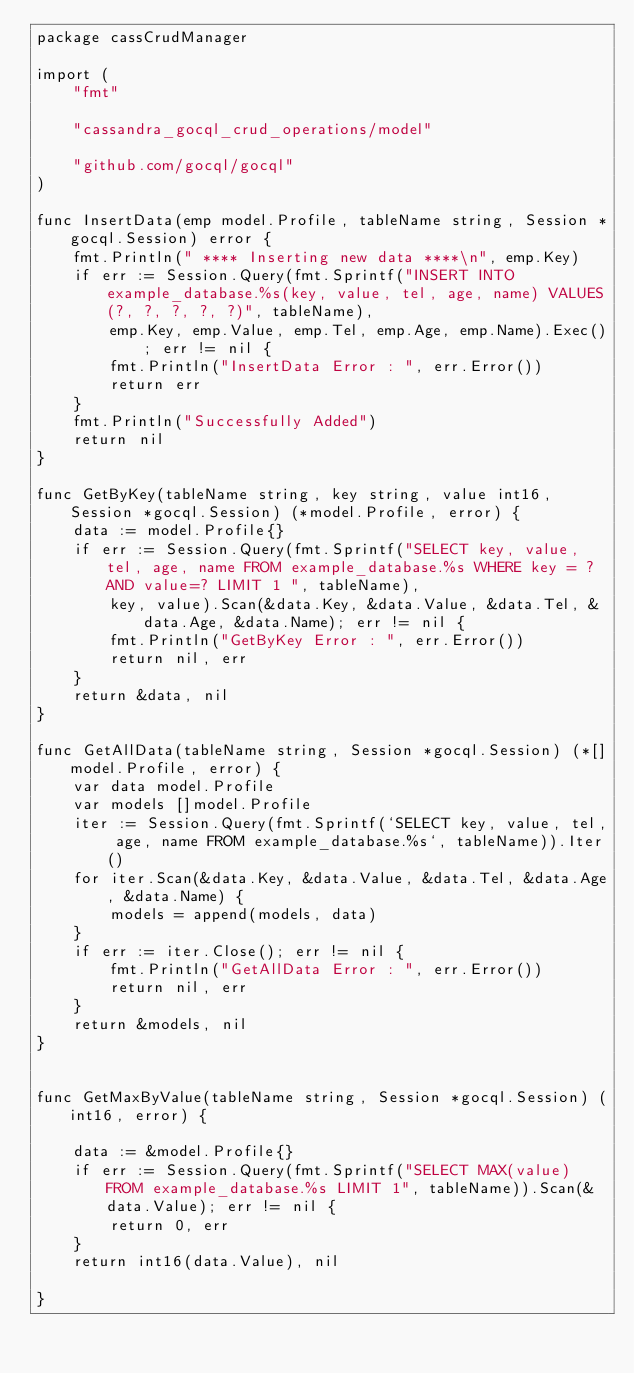<code> <loc_0><loc_0><loc_500><loc_500><_Go_>package cassCrudManager

import (
	"fmt"

	"cassandra_gocql_crud_operations/model"

	"github.com/gocql/gocql"
)

func InsertData(emp model.Profile, tableName string, Session *gocql.Session) error {
	fmt.Println(" **** Inserting new data ****\n", emp.Key)
	if err := Session.Query(fmt.Sprintf("INSERT INTO example_database.%s(key, value, tel, age, name) VALUES(?, ?, ?, ?, ?)", tableName),
		emp.Key, emp.Value, emp.Tel, emp.Age, emp.Name).Exec(); err != nil {
		fmt.Println("InsertData Error : ", err.Error())
		return err
	}
	fmt.Println("Successfully Added")
	return nil
}

func GetByKey(tableName string, key string, value int16, Session *gocql.Session) (*model.Profile, error) {
	data := model.Profile{}
	if err := Session.Query(fmt.Sprintf("SELECT key, value, tel, age, name FROM example_database.%s WHERE key = ? AND value=? LIMIT 1 ", tableName),
		key, value).Scan(&data.Key, &data.Value, &data.Tel, &data.Age, &data.Name); err != nil {
		fmt.Println("GetByKey Error : ", err.Error())
		return nil, err
	}
	return &data, nil
}

func GetAllData(tableName string, Session *gocql.Session) (*[]model.Profile, error) {
	var data model.Profile
	var models []model.Profile
	iter := Session.Query(fmt.Sprintf(`SELECT key, value, tel, age, name FROM example_database.%s`, tableName)).Iter()
	for iter.Scan(&data.Key, &data.Value, &data.Tel, &data.Age, &data.Name) {
		models = append(models, data)
	}
	if err := iter.Close(); err != nil {
		fmt.Println("GetAllData Error : ", err.Error())
		return nil, err
	}
	return &models, nil
}


func GetMaxByValue(tableName string, Session *gocql.Session) (int16, error) {

	data := &model.Profile{}
	if err := Session.Query(fmt.Sprintf("SELECT MAX(value) FROM example_database.%s LIMIT 1", tableName)).Scan(&data.Value); err != nil {
		return 0, err
	}
	return int16(data.Value), nil

}
</code> 